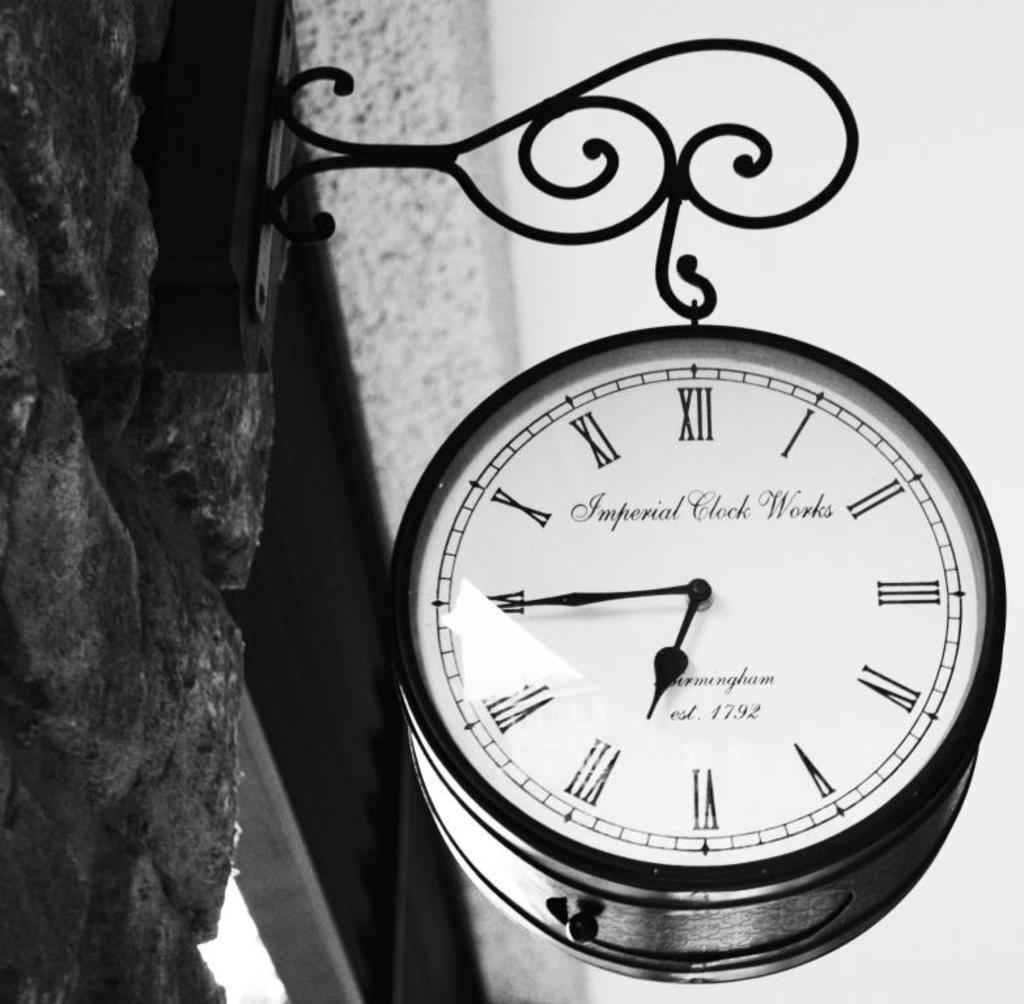<image>
Relay a brief, clear account of the picture shown. A clock that says Imperial Clock Works hangs from a brick wall 